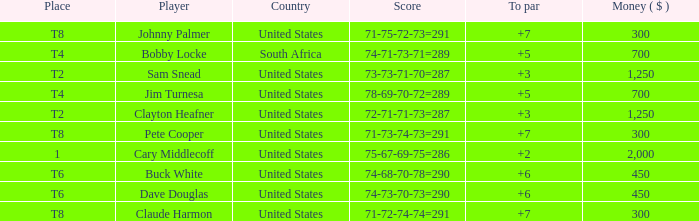What is the Johnny Palmer with a To larger than 6 Money sum? 300.0. 